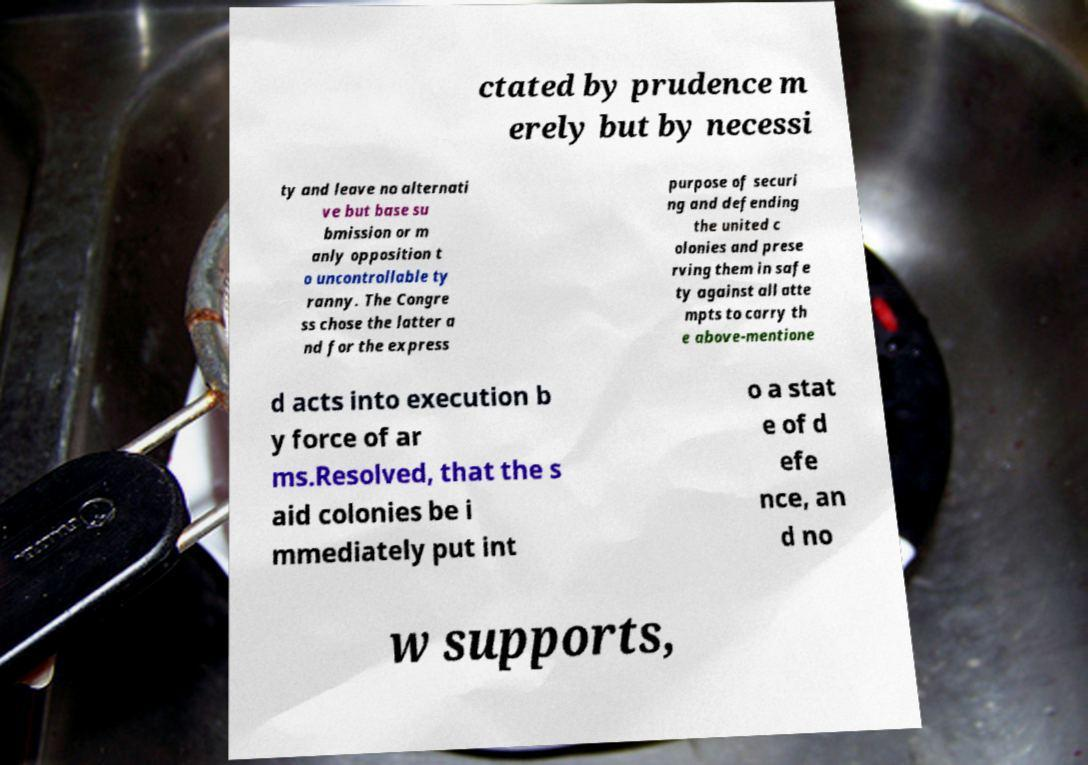Can you read and provide the text displayed in the image?This photo seems to have some interesting text. Can you extract and type it out for me? ctated by prudence m erely but by necessi ty and leave no alternati ve but base su bmission or m anly opposition t o uncontrollable ty ranny. The Congre ss chose the latter a nd for the express purpose of securi ng and defending the united c olonies and prese rving them in safe ty against all atte mpts to carry th e above-mentione d acts into execution b y force of ar ms.Resolved, that the s aid colonies be i mmediately put int o a stat e of d efe nce, an d no w supports, 